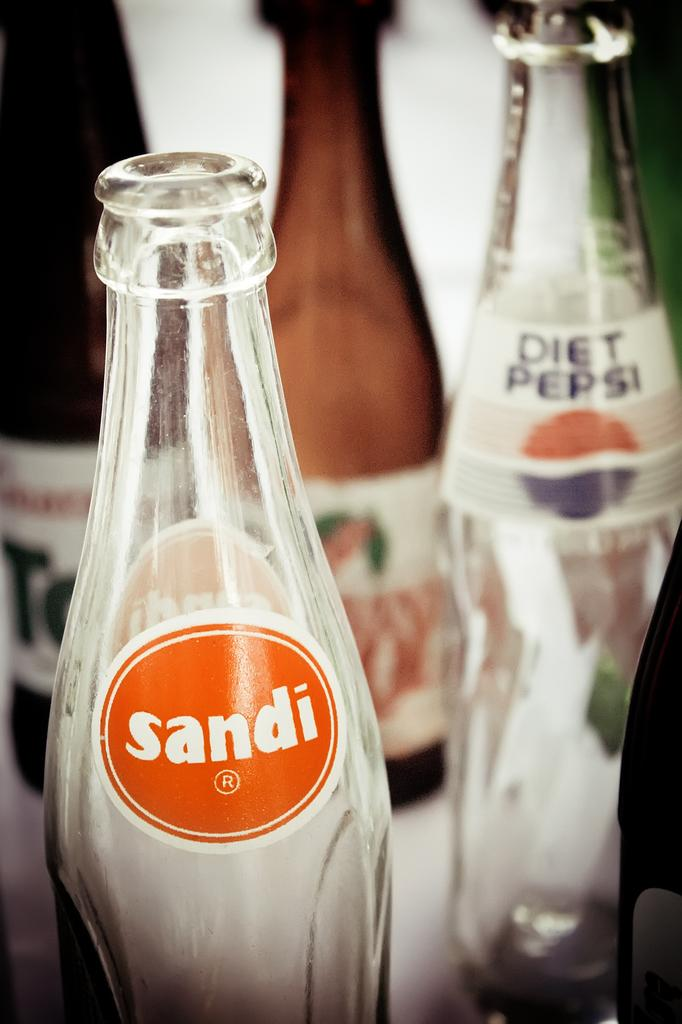<image>
Give a short and clear explanation of the subsequent image. Several glass beverage bottles together including diet pepsi. 